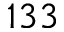<formula> <loc_0><loc_0><loc_500><loc_500>1 3 3</formula> 